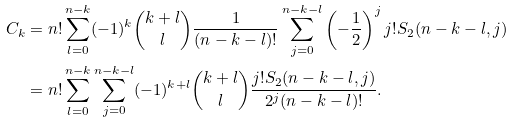Convert formula to latex. <formula><loc_0><loc_0><loc_500><loc_500>C _ { k } & = n ! \sum _ { l = 0 } ^ { n - k } ( - 1 ) ^ { k } \binom { k + l } { l } \frac { 1 } { ( n - k - l ) ! } \sum _ { j = 0 } ^ { n - k - l } \left ( - \frac { 1 } { 2 } \right ) ^ { j } j ! S _ { 2 } ( n - k - l , j ) \\ & = n ! \sum _ { l = 0 } ^ { n - k } \sum _ { j = 0 } ^ { n - k - l } ( - 1 ) ^ { k + l } \binom { k + l } { l } \frac { j ! S _ { 2 } ( n - k - l , j ) } { 2 ^ { j } ( n - k - l ) ! } .</formula> 